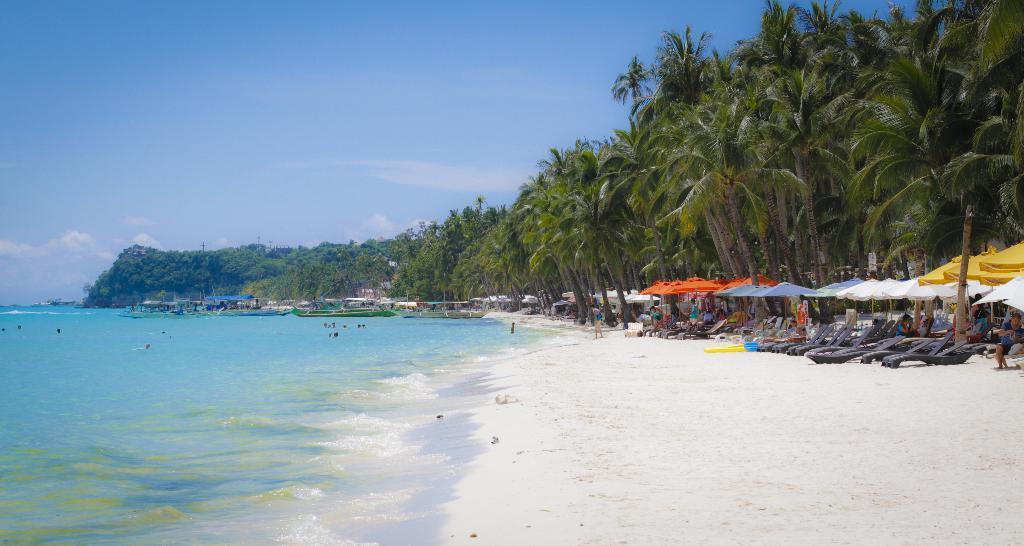Please provide a concise description of this image. This image is taken at the beach. In this image we can see a few people in the water. We can also see the beach beds and some people under the tents. Image also consists of trees, sand and also the sky with the clouds. 